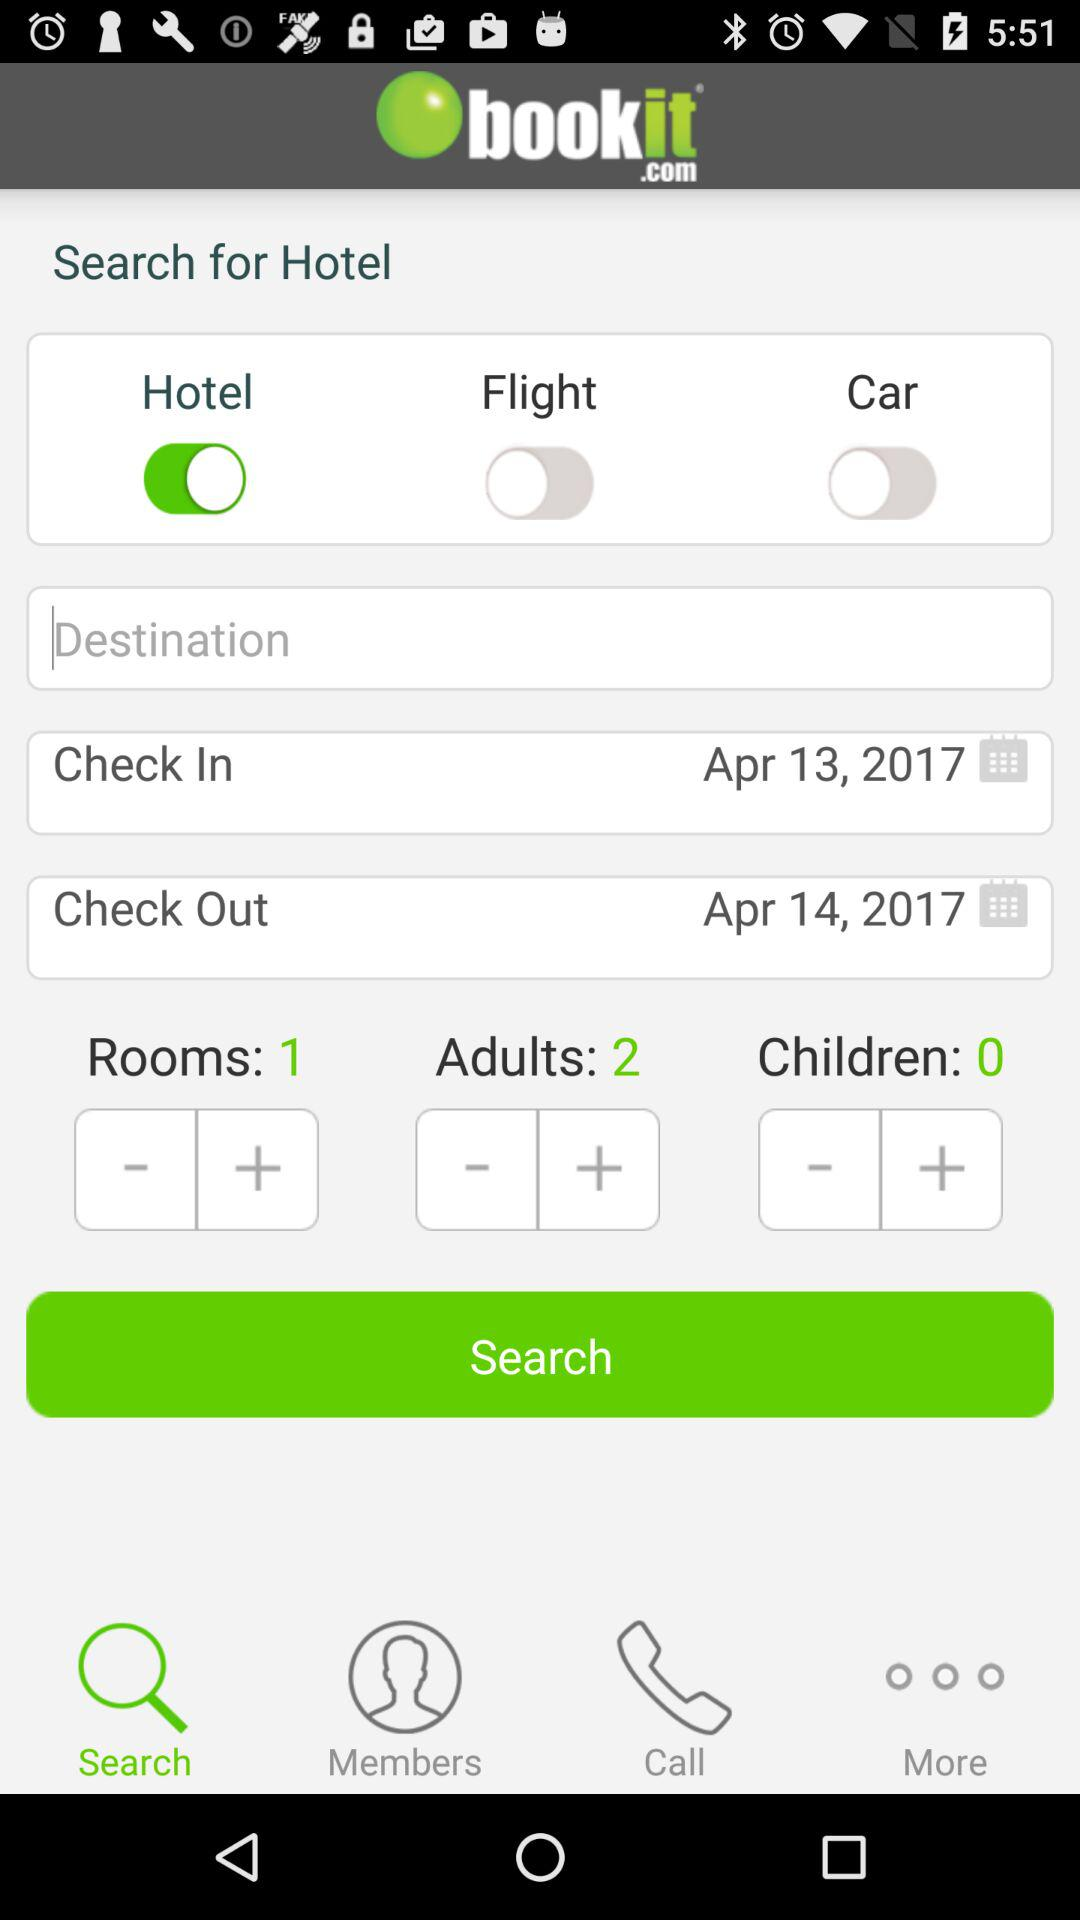How many adults are there? There are 2 adults. 